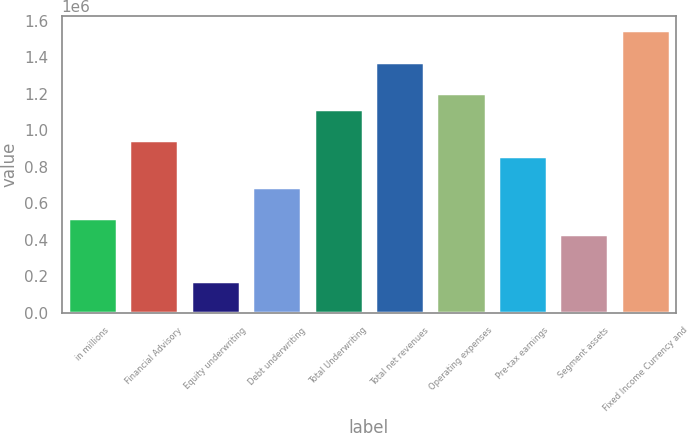<chart> <loc_0><loc_0><loc_500><loc_500><bar_chart><fcel>in millions<fcel>Financial Advisory<fcel>Equity underwriting<fcel>Debt underwriting<fcel>Total Underwriting<fcel>Total net revenues<fcel>Operating expenses<fcel>Pre-tax earnings<fcel>Segment assets<fcel>Fixed Income Currency and<nl><fcel>516267<fcel>946139<fcel>172370<fcel>688216<fcel>1.11809e+06<fcel>1.37601e+06<fcel>1.20406e+06<fcel>860165<fcel>430293<fcel>1.54796e+06<nl></chart> 